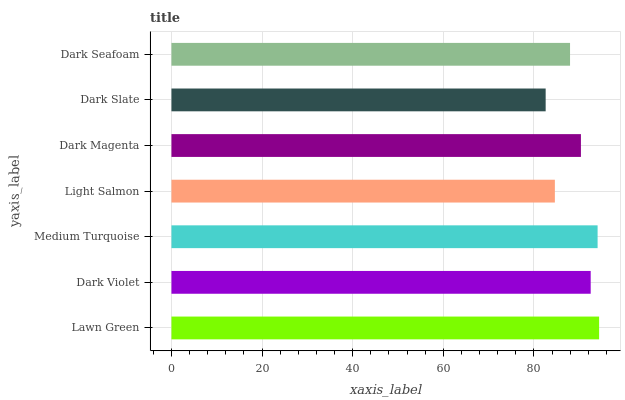Is Dark Slate the minimum?
Answer yes or no. Yes. Is Lawn Green the maximum?
Answer yes or no. Yes. Is Dark Violet the minimum?
Answer yes or no. No. Is Dark Violet the maximum?
Answer yes or no. No. Is Lawn Green greater than Dark Violet?
Answer yes or no. Yes. Is Dark Violet less than Lawn Green?
Answer yes or no. Yes. Is Dark Violet greater than Lawn Green?
Answer yes or no. No. Is Lawn Green less than Dark Violet?
Answer yes or no. No. Is Dark Magenta the high median?
Answer yes or no. Yes. Is Dark Magenta the low median?
Answer yes or no. Yes. Is Lawn Green the high median?
Answer yes or no. No. Is Dark Slate the low median?
Answer yes or no. No. 